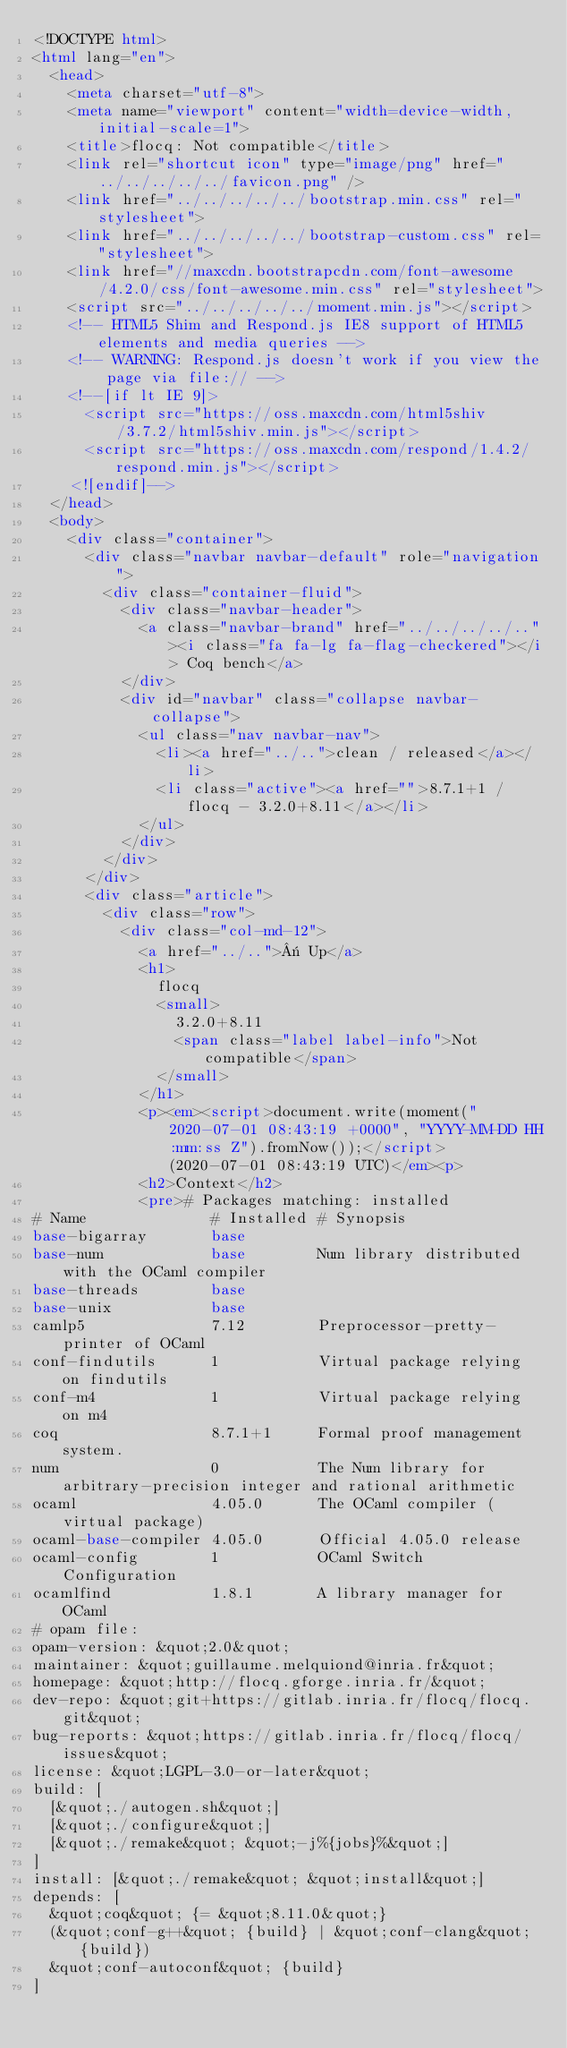Convert code to text. <code><loc_0><loc_0><loc_500><loc_500><_HTML_><!DOCTYPE html>
<html lang="en">
  <head>
    <meta charset="utf-8">
    <meta name="viewport" content="width=device-width, initial-scale=1">
    <title>flocq: Not compatible</title>
    <link rel="shortcut icon" type="image/png" href="../../../../../favicon.png" />
    <link href="../../../../../bootstrap.min.css" rel="stylesheet">
    <link href="../../../../../bootstrap-custom.css" rel="stylesheet">
    <link href="//maxcdn.bootstrapcdn.com/font-awesome/4.2.0/css/font-awesome.min.css" rel="stylesheet">
    <script src="../../../../../moment.min.js"></script>
    <!-- HTML5 Shim and Respond.js IE8 support of HTML5 elements and media queries -->
    <!-- WARNING: Respond.js doesn't work if you view the page via file:// -->
    <!--[if lt IE 9]>
      <script src="https://oss.maxcdn.com/html5shiv/3.7.2/html5shiv.min.js"></script>
      <script src="https://oss.maxcdn.com/respond/1.4.2/respond.min.js"></script>
    <![endif]-->
  </head>
  <body>
    <div class="container">
      <div class="navbar navbar-default" role="navigation">
        <div class="container-fluid">
          <div class="navbar-header">
            <a class="navbar-brand" href="../../../../.."><i class="fa fa-lg fa-flag-checkered"></i> Coq bench</a>
          </div>
          <div id="navbar" class="collapse navbar-collapse">
            <ul class="nav navbar-nav">
              <li><a href="../..">clean / released</a></li>
              <li class="active"><a href="">8.7.1+1 / flocq - 3.2.0+8.11</a></li>
            </ul>
          </div>
        </div>
      </div>
      <div class="article">
        <div class="row">
          <div class="col-md-12">
            <a href="../..">« Up</a>
            <h1>
              flocq
              <small>
                3.2.0+8.11
                <span class="label label-info">Not compatible</span>
              </small>
            </h1>
            <p><em><script>document.write(moment("2020-07-01 08:43:19 +0000", "YYYY-MM-DD HH:mm:ss Z").fromNow());</script> (2020-07-01 08:43:19 UTC)</em><p>
            <h2>Context</h2>
            <pre># Packages matching: installed
# Name              # Installed # Synopsis
base-bigarray       base
base-num            base        Num library distributed with the OCaml compiler
base-threads        base
base-unix           base
camlp5              7.12        Preprocessor-pretty-printer of OCaml
conf-findutils      1           Virtual package relying on findutils
conf-m4             1           Virtual package relying on m4
coq                 8.7.1+1     Formal proof management system.
num                 0           The Num library for arbitrary-precision integer and rational arithmetic
ocaml               4.05.0      The OCaml compiler (virtual package)
ocaml-base-compiler 4.05.0      Official 4.05.0 release
ocaml-config        1           OCaml Switch Configuration
ocamlfind           1.8.1       A library manager for OCaml
# opam file:
opam-version: &quot;2.0&quot;
maintainer: &quot;guillaume.melquiond@inria.fr&quot;
homepage: &quot;http://flocq.gforge.inria.fr/&quot;
dev-repo: &quot;git+https://gitlab.inria.fr/flocq/flocq.git&quot;
bug-reports: &quot;https://gitlab.inria.fr/flocq/flocq/issues&quot;
license: &quot;LGPL-3.0-or-later&quot;
build: [
  [&quot;./autogen.sh&quot;]
  [&quot;./configure&quot;]
  [&quot;./remake&quot; &quot;-j%{jobs}%&quot;]
]
install: [&quot;./remake&quot; &quot;install&quot;]
depends: [
  &quot;coq&quot; {= &quot;8.11.0&quot;}
  (&quot;conf-g++&quot; {build} | &quot;conf-clang&quot; {build})
  &quot;conf-autoconf&quot; {build}
]</code> 